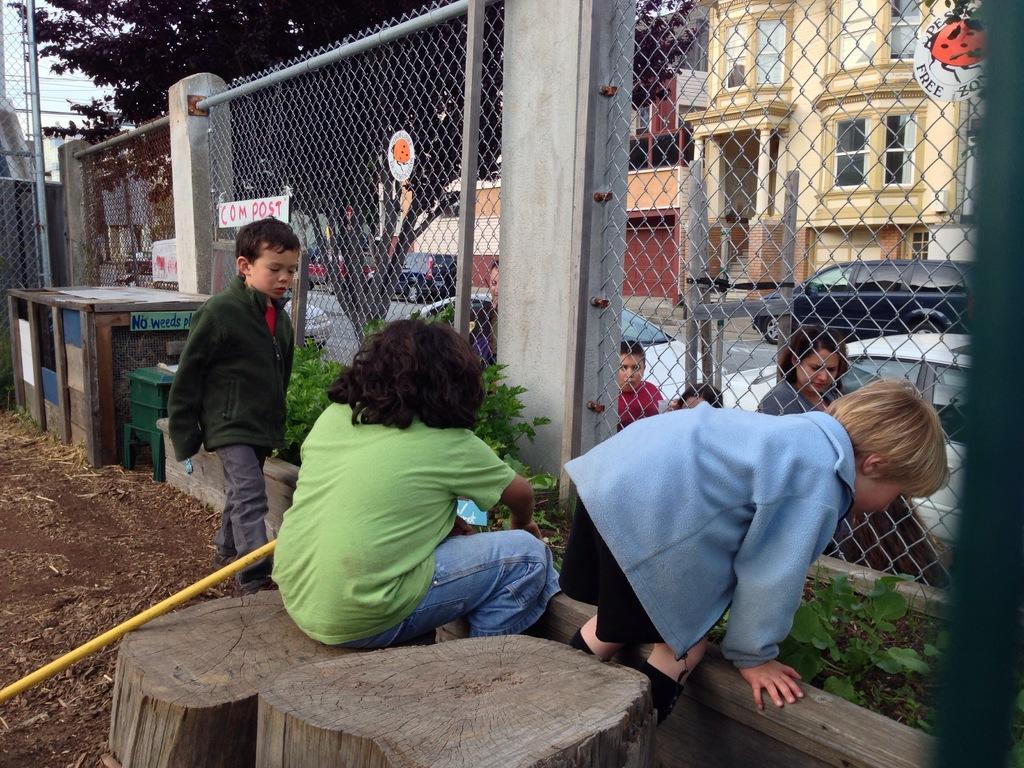Could you give a brief overview of what you see in this image? In this image I can see few children and between them I can see fencing. In the background I can see few trees, few plants and few buildings. I can also see a yellow color thing on the left side this image. 